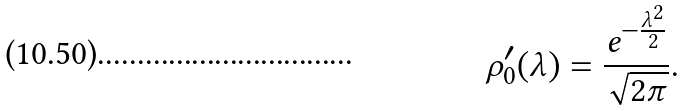<formula> <loc_0><loc_0><loc_500><loc_500>\rho _ { 0 } ^ { \prime } ( \lambda ) = \frac { e ^ { - \frac { \lambda ^ { 2 } } 2 } } { \sqrt { 2 \pi } } .</formula> 